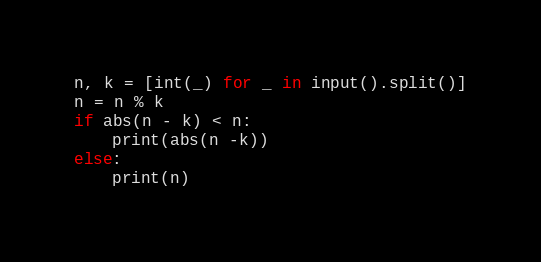<code> <loc_0><loc_0><loc_500><loc_500><_Python_>n, k = [int(_) for _ in input().split()]
n = n % k
if abs(n - k) < n:
    print(abs(n -k))
else:
    print(n)</code> 